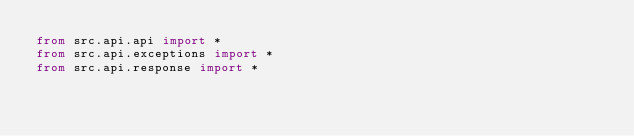<code> <loc_0><loc_0><loc_500><loc_500><_Python_>from src.api.api import *
from src.api.exceptions import *
from src.api.response import *

</code> 